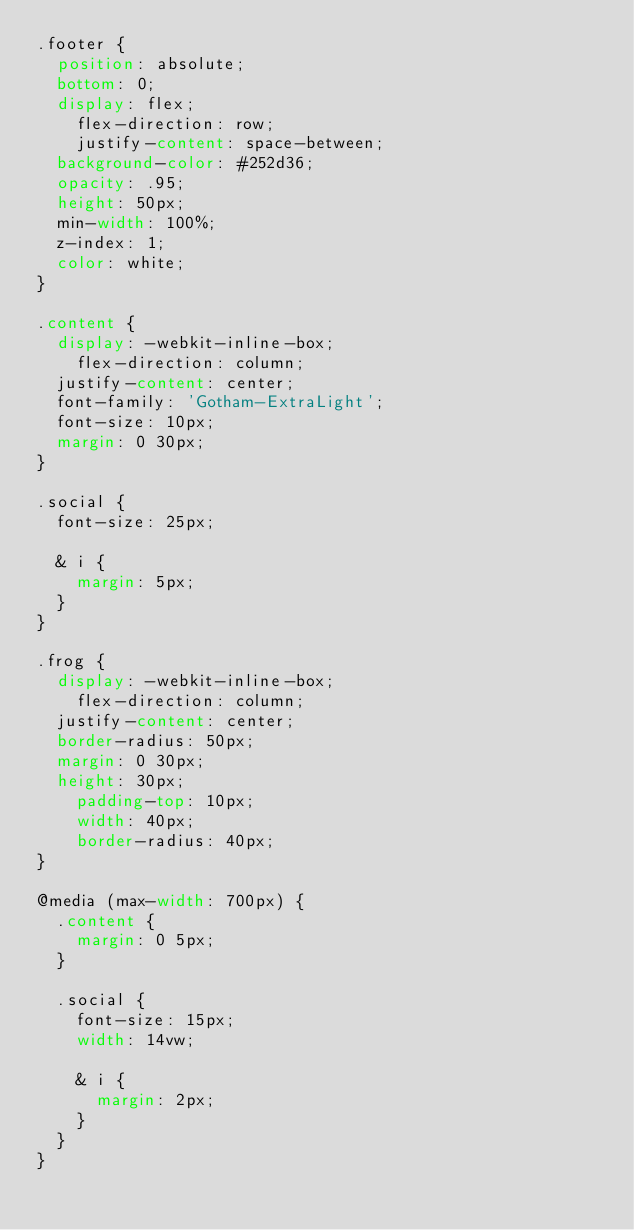<code> <loc_0><loc_0><loc_500><loc_500><_CSS_>.footer {
	position: absolute;
	bottom: 0;
	display: flex;
    flex-direction: row;
    justify-content: space-between;
	background-color: #252d36;
	opacity: .95;
	height: 50px;
	min-width: 100%;
	z-index: 1;
	color: white;
}

.content {
	display: -webkit-inline-box;
    flex-direction: column;
	justify-content: center;
	font-family: 'Gotham-ExtraLight';
	font-size: 10px;
	margin: 0 30px;
}

.social {
	font-size: 25px;

	& i {
		margin: 5px;
	}
}

.frog {
	display: -webkit-inline-box;
    flex-direction: column;
	justify-content: center;
	border-radius: 50px;
	margin: 0 30px;
	height: 30px;
    padding-top: 10px;
    width: 40px;
    border-radius: 40px;
}

@media (max-width: 700px) {
	.content {
		margin: 0 5px;
	}

	.social {
		font-size: 15px;
		width: 14vw;
	
		& i {
			margin: 2px;
		}
	}
}
</code> 